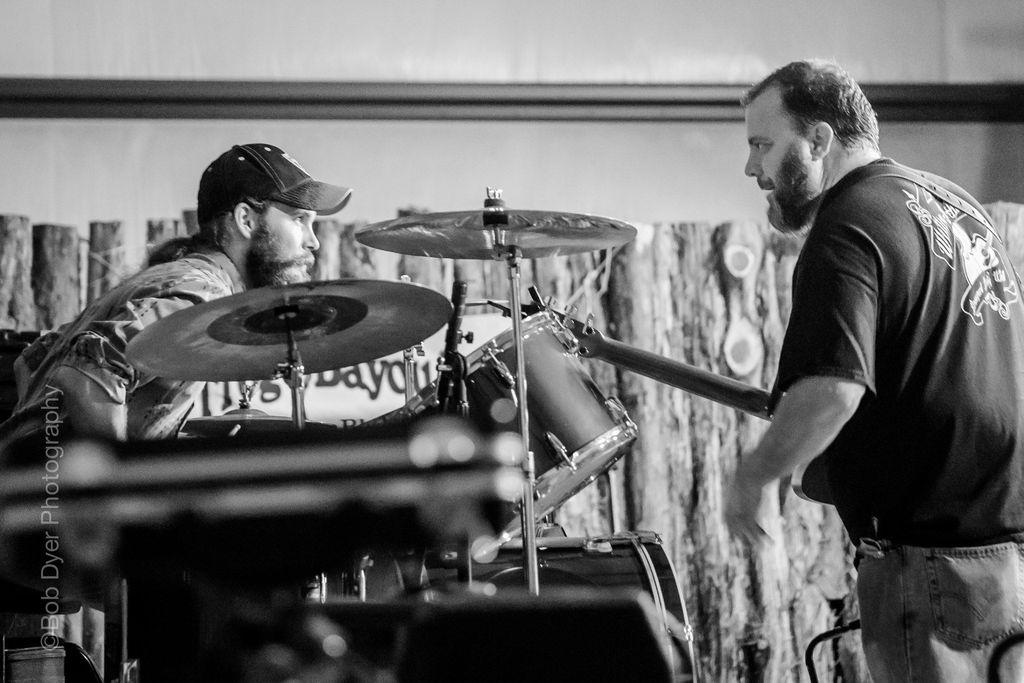How many people are in the image? There are two persons in the image. What is located between the two persons? There is a musical instrument between the two persons. What type of object can be seen in the image that is typically used for covering or dividing spaces? There is a curtain in the image. What type of architectural feature is visible at the top of the image? There is a wall visible at the top of the image. What type of bead is being used by the writer in the image? There is no writer or bead present in the image. What type of railway can be seen in the image? There is no railway present in the image. 